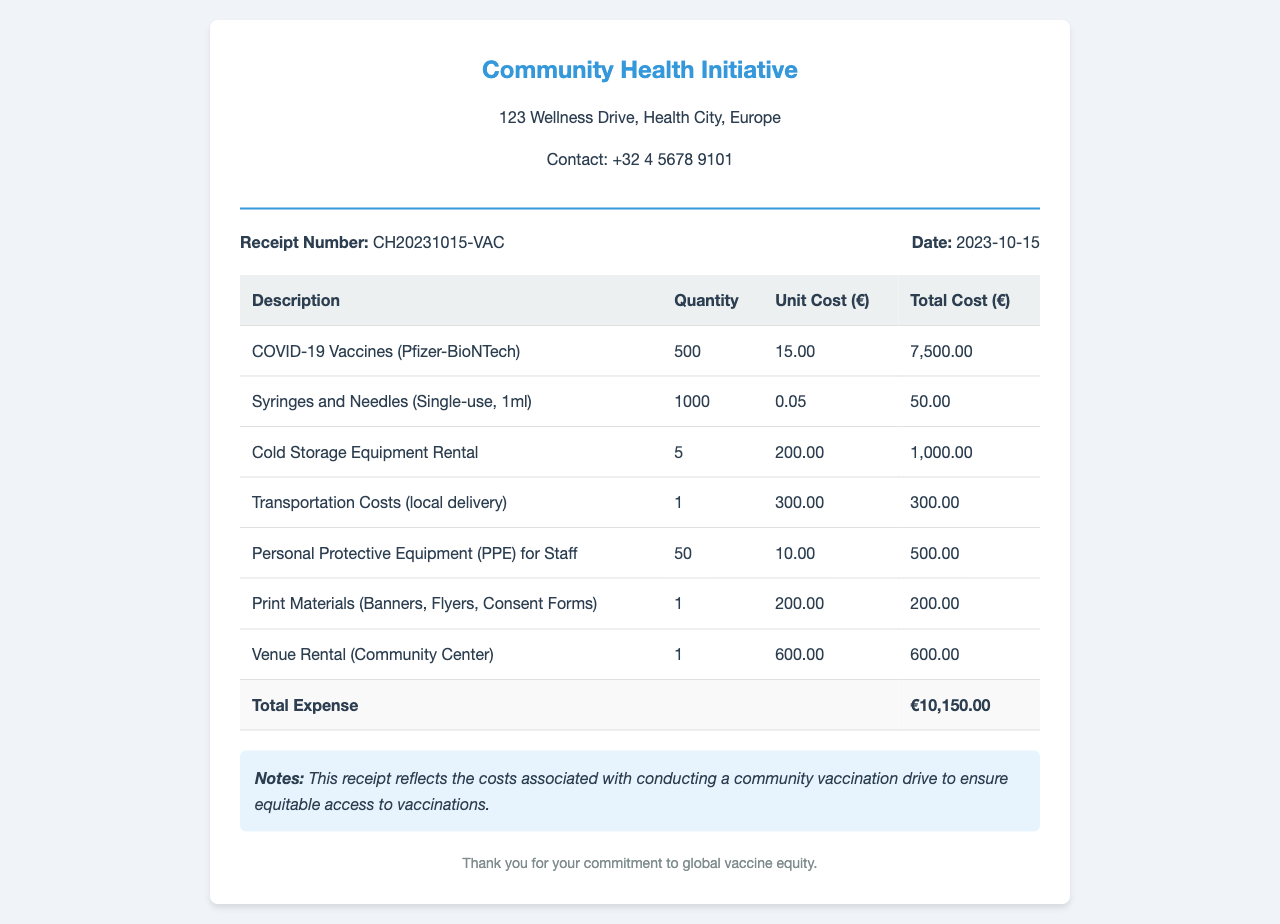What is the organization name? The organization name is shown at the top of the receipt.
Answer: Community Health Initiative What is the receipt number? The receipt number is located in the receipt details section.
Answer: CH20231015-VAC What is the date of the receipt? The date is also part of the receipt details.
Answer: 2023-10-15 How many COVID-19 vaccines were purchased? The number of vaccines is specified in the table of contents.
Answer: 500 What is the unit cost of syringes and needles? The unit cost for syringes and needles can be found in the corresponding table row.
Answer: 0.05 What is the total expense for the vaccination drive? The total expense is calculated and displayed in the summary row at the bottom of the table.
Answer: €10,150.00 How much did the cold storage equipment rental cost? The cost is provided in the itemized expenses in the table.
Answer: 1,000.00 What notes accompany the receipt? The notes section provides additional context regarding the receipt’s purpose.
Answer: This receipt reflects the costs associated with conducting a community vaccination drive to ensure equitable access to vaccinations How many personal protective equipment units were purchased? The quantity for PPE is specified in the relevant table row.
Answer: 50 What is the venue rented for the vaccination campaign? The venue name is noted in the expenses table.
Answer: Community Center 